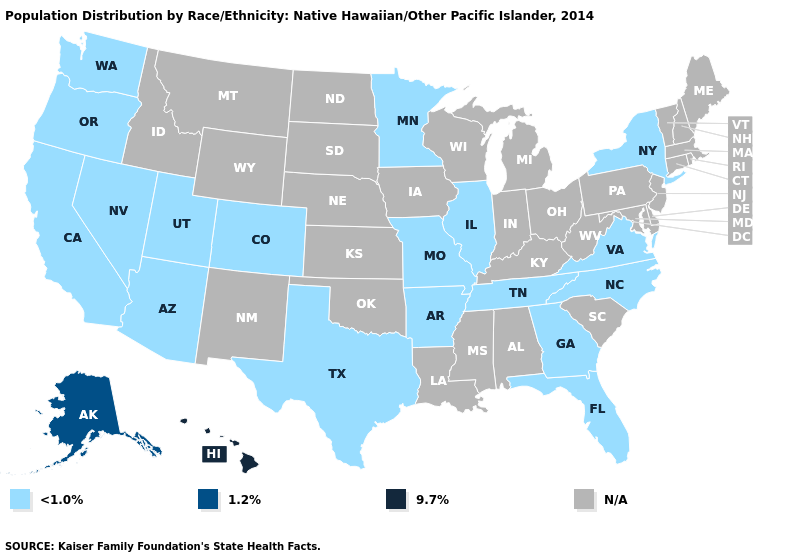What is the value of Maine?
Answer briefly. N/A. Name the states that have a value in the range 1.2%?
Short answer required. Alaska. What is the highest value in the USA?
Concise answer only. 9.7%. What is the lowest value in states that border Georgia?
Keep it brief. <1.0%. What is the highest value in states that border Wyoming?
Be succinct. <1.0%. Name the states that have a value in the range N/A?
Concise answer only. Alabama, Connecticut, Delaware, Idaho, Indiana, Iowa, Kansas, Kentucky, Louisiana, Maine, Maryland, Massachusetts, Michigan, Mississippi, Montana, Nebraska, New Hampshire, New Jersey, New Mexico, North Dakota, Ohio, Oklahoma, Pennsylvania, Rhode Island, South Carolina, South Dakota, Vermont, West Virginia, Wisconsin, Wyoming. Among the states that border Alabama , which have the lowest value?
Keep it brief. Florida, Georgia, Tennessee. Among the states that border Kentucky , which have the highest value?
Quick response, please. Illinois, Missouri, Tennessee, Virginia. What is the value of Kentucky?
Answer briefly. N/A. What is the value of Nevada?
Give a very brief answer. <1.0%. How many symbols are there in the legend?
Answer briefly. 4. What is the lowest value in the USA?
Give a very brief answer. <1.0%. Among the states that border North Dakota , which have the highest value?
Give a very brief answer. Minnesota. 